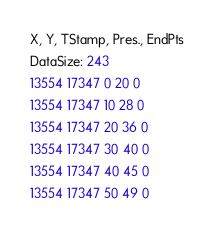Convert code to text. <code><loc_0><loc_0><loc_500><loc_500><_SML_>X, Y, TStamp, Pres., EndPts
DataSize: 243
13554 17347 0 20 0
13554 17347 10 28 0
13554 17347 20 36 0
13554 17347 30 40 0
13554 17347 40 45 0
13554 17347 50 49 0</code> 